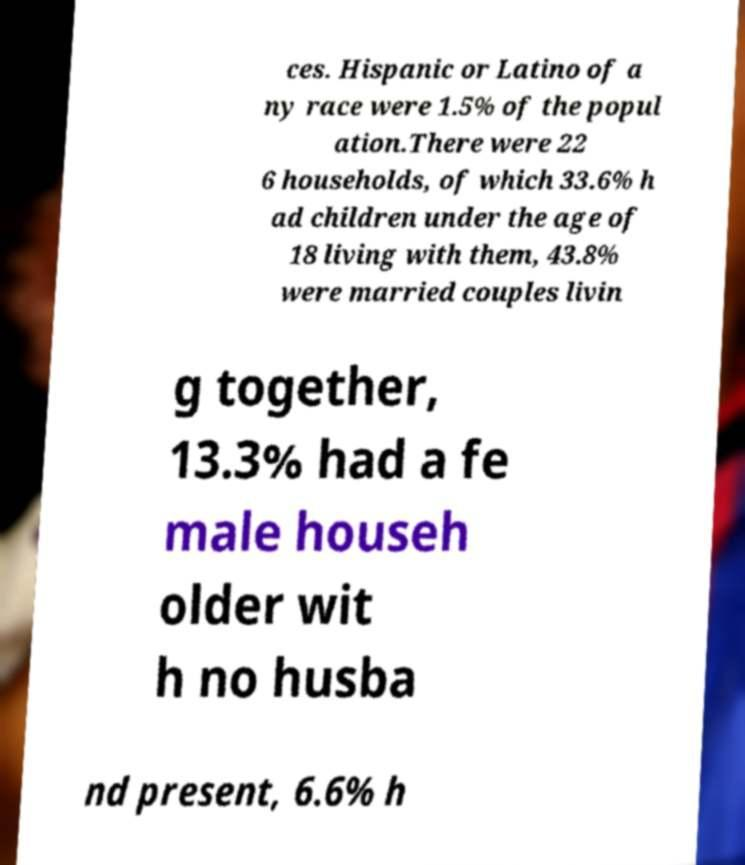Could you assist in decoding the text presented in this image and type it out clearly? ces. Hispanic or Latino of a ny race were 1.5% of the popul ation.There were 22 6 households, of which 33.6% h ad children under the age of 18 living with them, 43.8% were married couples livin g together, 13.3% had a fe male househ older wit h no husba nd present, 6.6% h 